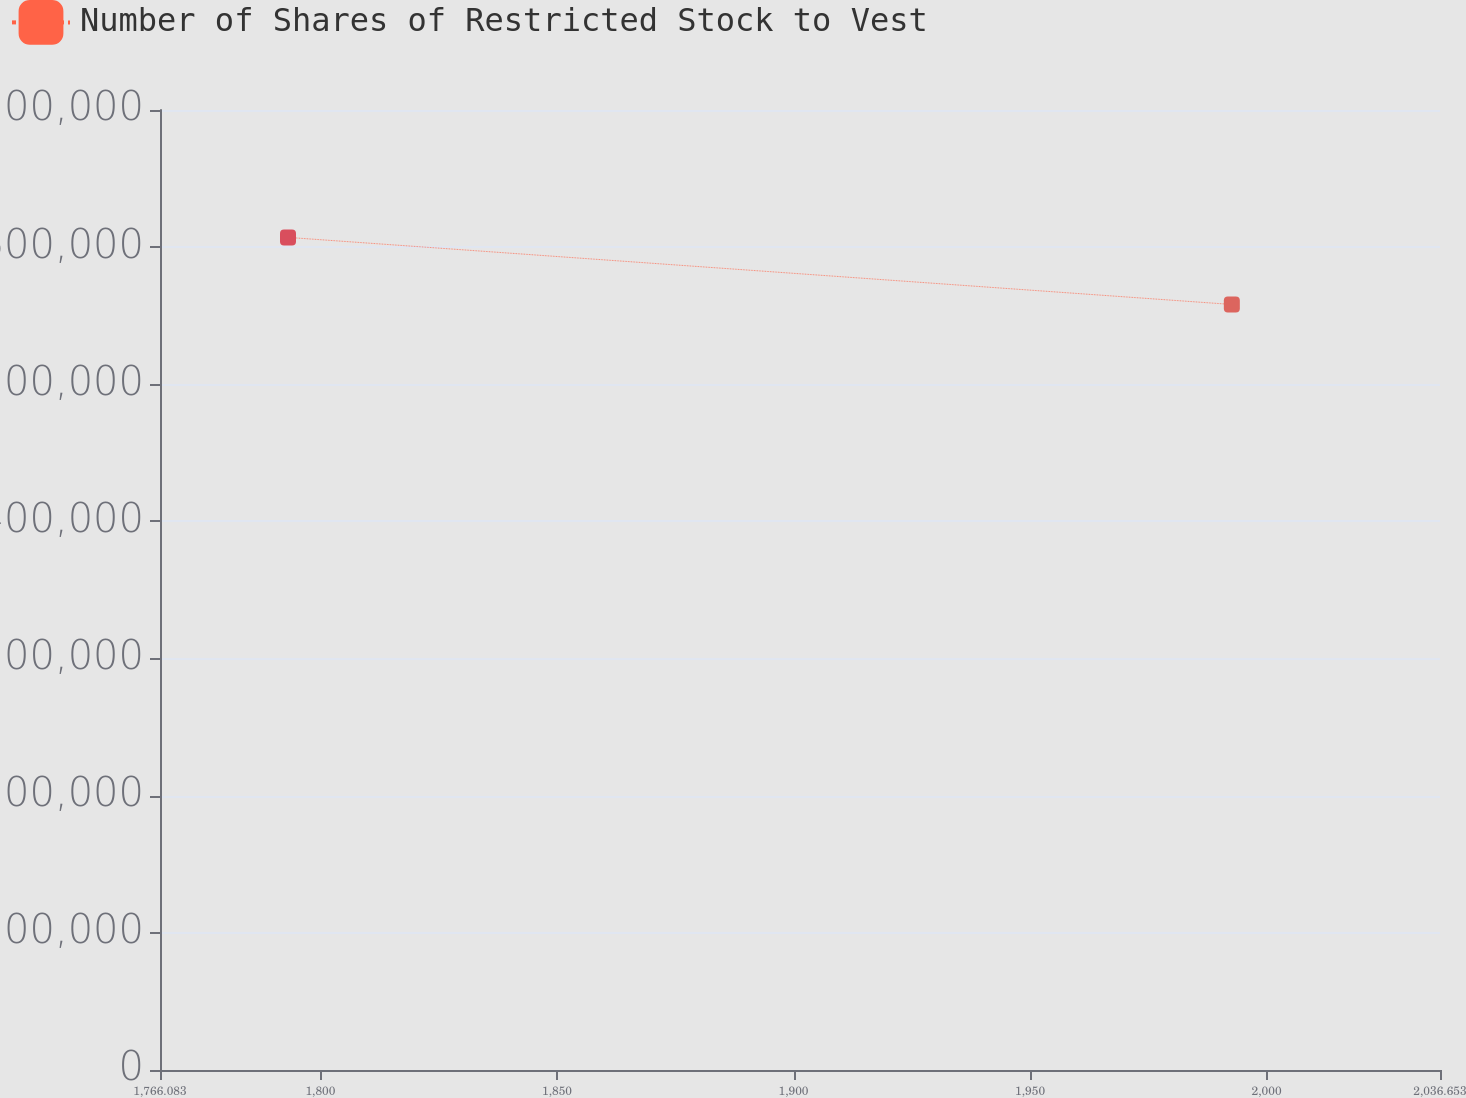Convert chart to OTSL. <chart><loc_0><loc_0><loc_500><loc_500><line_chart><ecel><fcel>Number of Shares of Restricted Stock to Vest<nl><fcel>1793.14<fcel>607106<nl><fcel>1992.65<fcel>558200<nl><fcel>2063.71<fcel>91271.5<nl></chart> 